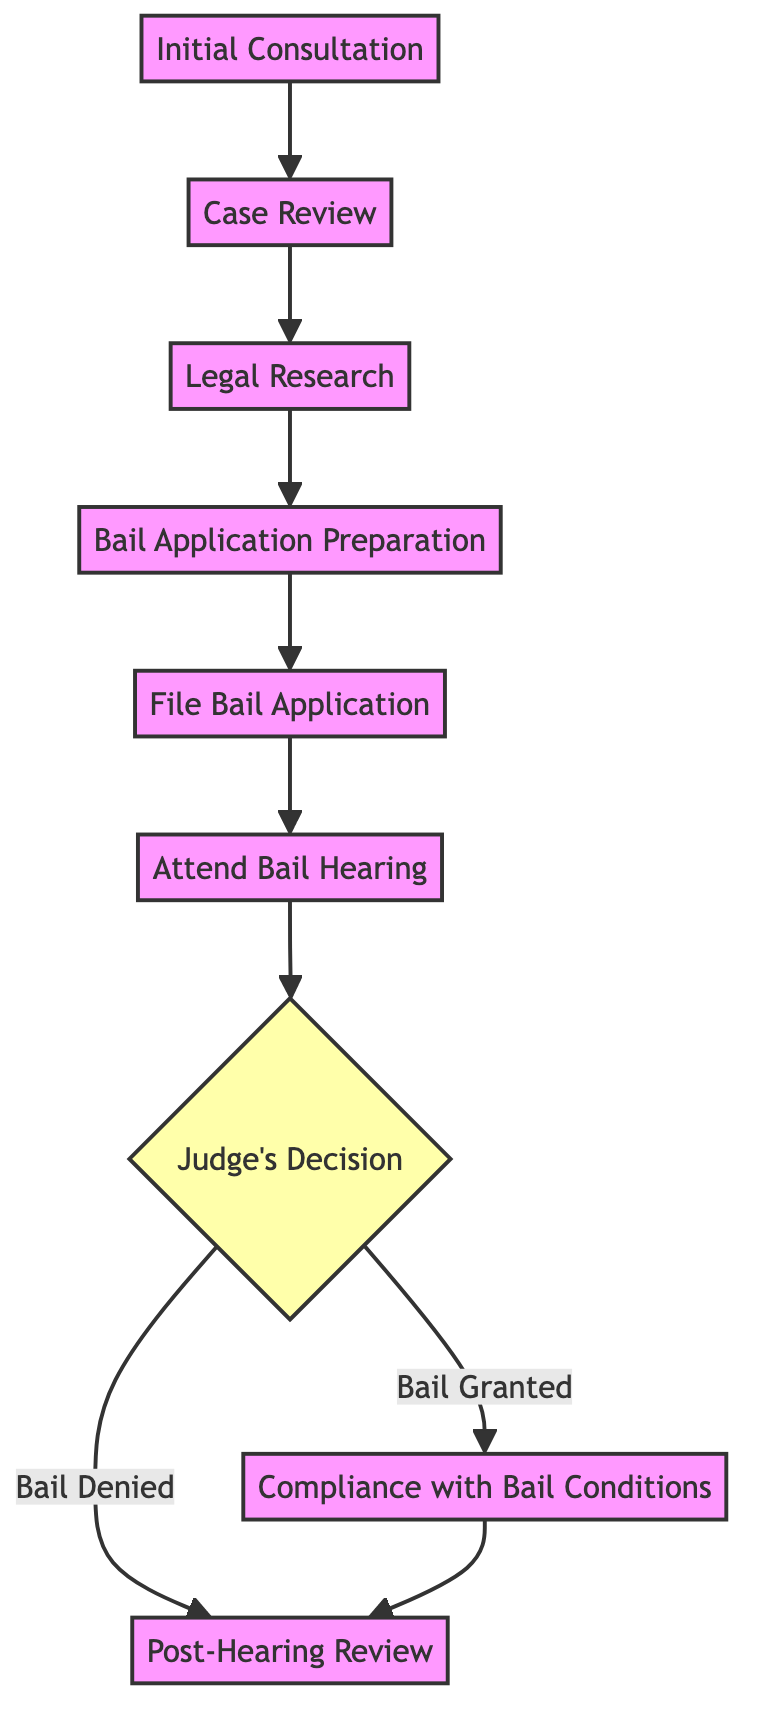What is the first step in the procedure? The first step is "Initial Consultation," which is clearly indicated at the start of the flowchart.
Answer: Initial Consultation How many steps are there in total? Counting all the steps from the diagram, there are nine steps leading from the initial action to compliance or post-hearing review.
Answer: 9 What follows the "Attend Bail Hearing"? According to the flow of the diagram, after "Attend Bail Hearing," the next step is the decision made by the judge, which is labeled as "Judge's Decision."
Answer: Judge's Decision What are the two possible outcomes after the "Judge's Decision"? The diagram shows two outcomes after "Judge's Decision": "Bail Granted" leading to "Compliance with Bail Conditions" and "Bail Denied" leading to "Post-Hearing Review."
Answer: Bail Granted and Bail Denied If bail is granted, what is the next step? The next step after "Bail Granted" is "Compliance with Bail Conditions," indicating that the client must meet specific terms following their release.
Answer: Compliance with Bail Conditions What step involves preparing legal documents for bail? The step dedicated to preparing legal documents for bail is "Bail Application Preparation," as indicated in the flowchart.
Answer: Bail Application Preparation What is the role of the lawyer at the "Attend Bail Hearing" step? At the "Attend Bail Hearing" step, the lawyer represents the client, presenting arguments and evidence to support their request for bail.
Answer: Represent the client Which step comes immediately after the "File Bail Application"? Immediately after "File Bail Application," the next step in the process is "Attend Bail Hearing," indicating that the application leads directly to a hearing.
Answer: Attend Bail Hearing What must the client do after bail is granted? After bail is granted, the client is required to ensure understanding and compliance with the bail conditions until the trial date.
Answer: Compliance with Bail Conditions 